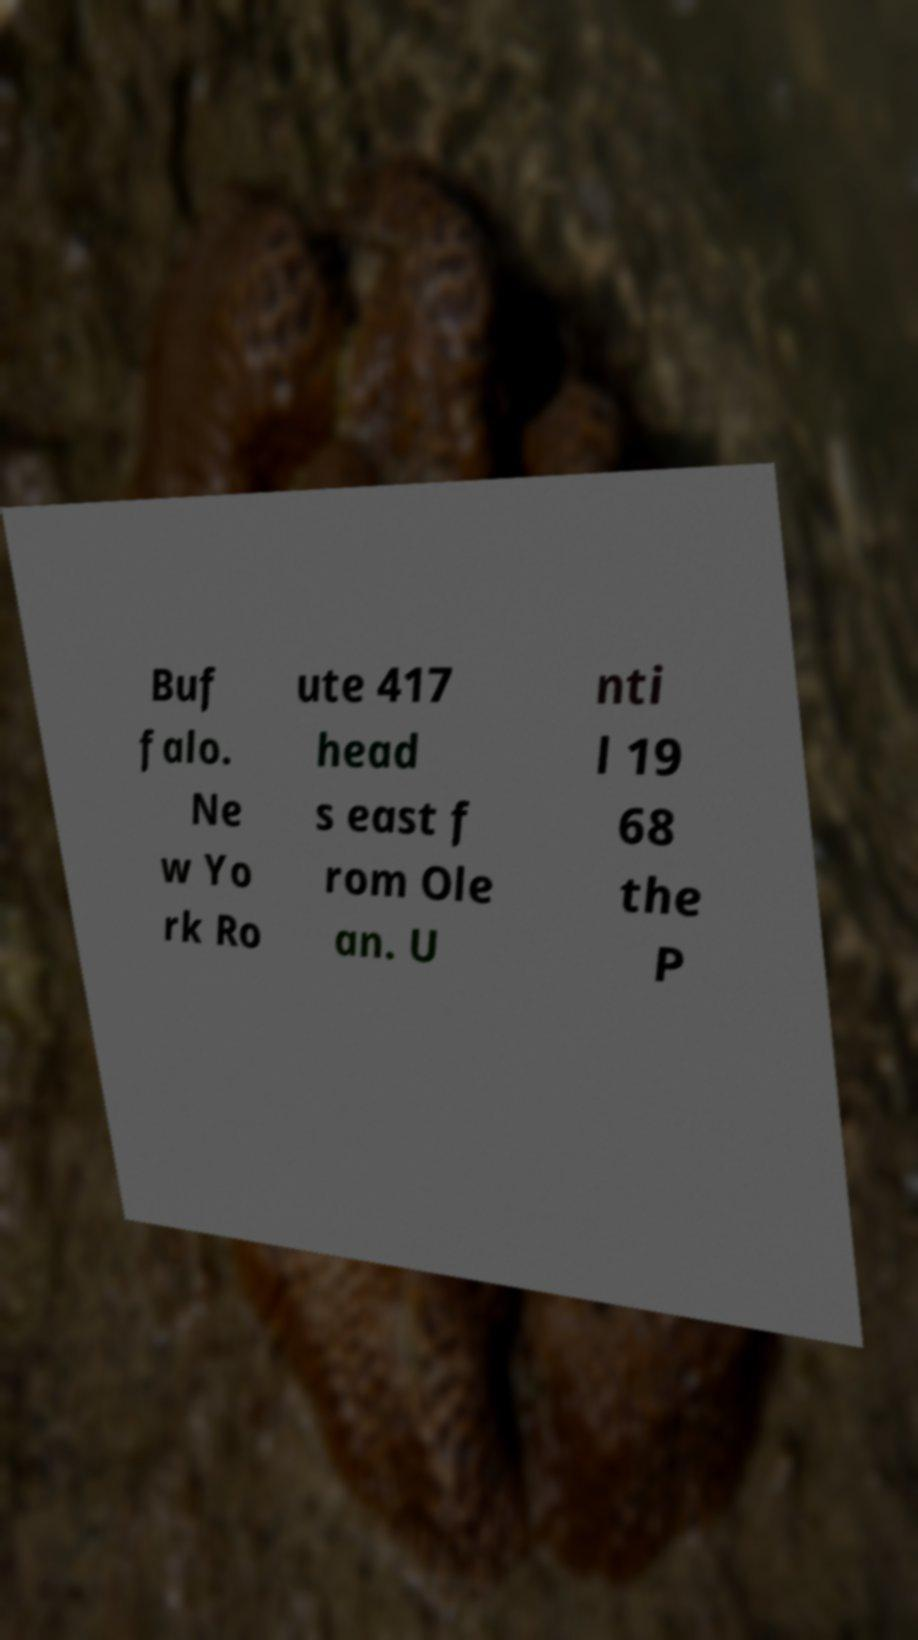Could you assist in decoding the text presented in this image and type it out clearly? Buf falo. Ne w Yo rk Ro ute 417 head s east f rom Ole an. U nti l 19 68 the P 